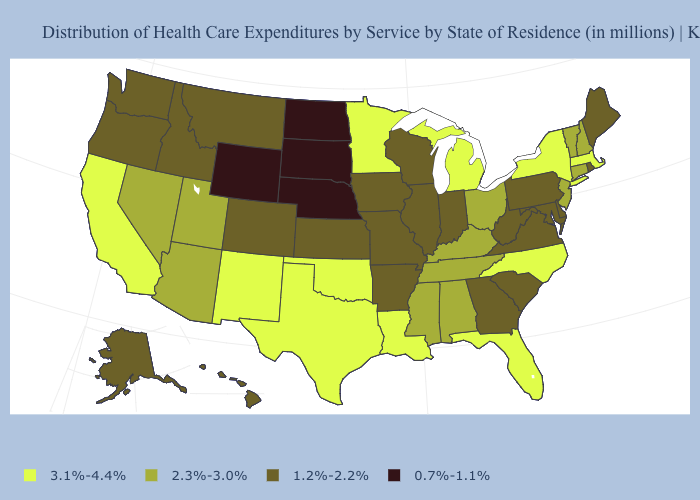Which states have the lowest value in the USA?
Give a very brief answer. Nebraska, North Dakota, South Dakota, Wyoming. What is the value of Delaware?
Keep it brief. 1.2%-2.2%. What is the highest value in states that border Connecticut?
Concise answer only. 3.1%-4.4%. Does the map have missing data?
Answer briefly. No. Is the legend a continuous bar?
Keep it brief. No. Name the states that have a value in the range 3.1%-4.4%?
Keep it brief. California, Florida, Louisiana, Massachusetts, Michigan, Minnesota, New Mexico, New York, North Carolina, Oklahoma, Texas. Among the states that border Nevada , which have the lowest value?
Give a very brief answer. Idaho, Oregon. Name the states that have a value in the range 3.1%-4.4%?
Concise answer only. California, Florida, Louisiana, Massachusetts, Michigan, Minnesota, New Mexico, New York, North Carolina, Oklahoma, Texas. What is the value of Wyoming?
Keep it brief. 0.7%-1.1%. What is the value of Pennsylvania?
Keep it brief. 1.2%-2.2%. What is the highest value in the Northeast ?
Short answer required. 3.1%-4.4%. Does Mississippi have the highest value in the USA?
Keep it brief. No. Does North Dakota have the lowest value in the USA?
Keep it brief. Yes. Does Maine have the lowest value in the Northeast?
Be succinct. Yes. 